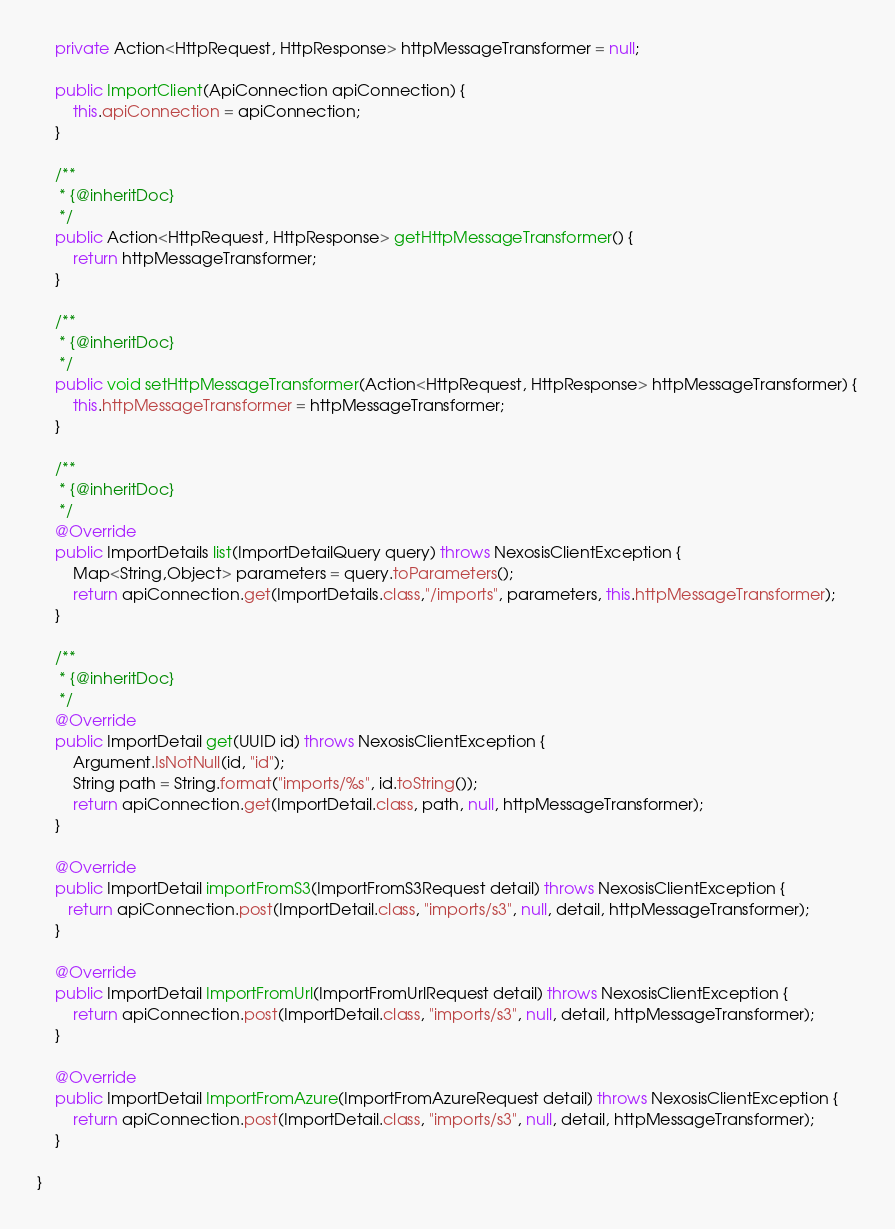<code> <loc_0><loc_0><loc_500><loc_500><_Java_>    private Action<HttpRequest, HttpResponse> httpMessageTransformer = null;

    public ImportClient(ApiConnection apiConnection) {
        this.apiConnection = apiConnection;
    }

    /**
     * {@inheritDoc}
     */
    public Action<HttpRequest, HttpResponse> getHttpMessageTransformer() {
        return httpMessageTransformer;
    }

    /**
     * {@inheritDoc}
     */
    public void setHttpMessageTransformer(Action<HttpRequest, HttpResponse> httpMessageTransformer) {
        this.httpMessageTransformer = httpMessageTransformer;
    }

    /**
     * {@inheritDoc}
     */
    @Override
    public ImportDetails list(ImportDetailQuery query) throws NexosisClientException {
        Map<String,Object> parameters = query.toParameters();
        return apiConnection.get(ImportDetails.class,"/imports", parameters, this.httpMessageTransformer);
    }

    /**
     * {@inheritDoc}
     */
    @Override
    public ImportDetail get(UUID id) throws NexosisClientException {
        Argument.IsNotNull(id, "id");
        String path = String.format("imports/%s", id.toString());
        return apiConnection.get(ImportDetail.class, path, null, httpMessageTransformer);
    }

    @Override
    public ImportDetail importFromS3(ImportFromS3Request detail) throws NexosisClientException {
       return apiConnection.post(ImportDetail.class, "imports/s3", null, detail, httpMessageTransformer);
    }

    @Override
    public ImportDetail ImportFromUrl(ImportFromUrlRequest detail) throws NexosisClientException {
        return apiConnection.post(ImportDetail.class, "imports/s3", null, detail, httpMessageTransformer);
    }

    @Override
    public ImportDetail ImportFromAzure(ImportFromAzureRequest detail) throws NexosisClientException {
        return apiConnection.post(ImportDetail.class, "imports/s3", null, detail, httpMessageTransformer);
    }

}
</code> 